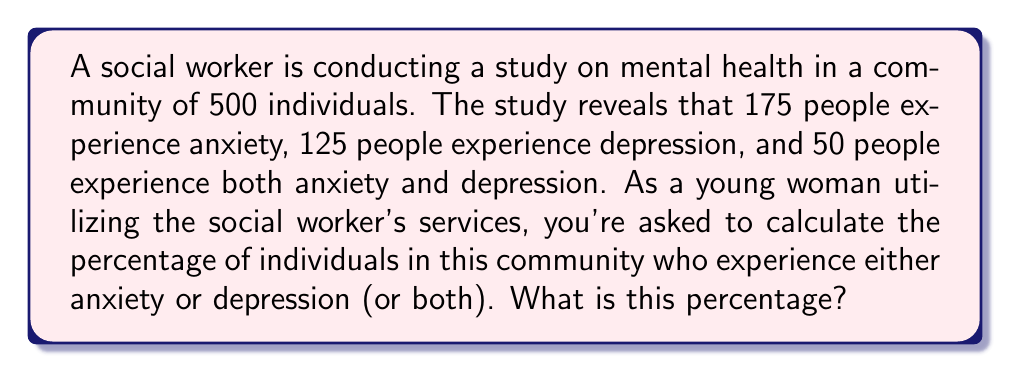Can you answer this question? To solve this problem, we'll use the concept of sets and the inclusion-exclusion principle. Let's break it down step-by-step:

1. Define our sets:
   A = people with anxiety
   D = people with depression

2. We know:
   $|A| = 175$ (number of people with anxiety)
   $|D| = 125$ (number of people with depression)
   $|A \cap D| = 50$ (number of people with both anxiety and depression)
   Total population = 500

3. We want to find $|A \cup D|$ (number of people with anxiety or depression or both)

4. The inclusion-exclusion principle states:
   $|A \cup D| = |A| + |D| - |A \cap D|$

5. Plugging in our values:
   $|A \cup D| = 175 + 125 - 50 = 250$

6. To calculate the percentage, we use the formula:
   $\text{Percentage} = \frac{\text{Part}}{\text{Whole}} \times 100\%$

7. In this case:
   $\text{Percentage} = \frac{250}{500} \times 100\% = 0.5 \times 100\% = 50\%$

Therefore, 50% of the community experiences either anxiety or depression (or both).
Answer: 50% 